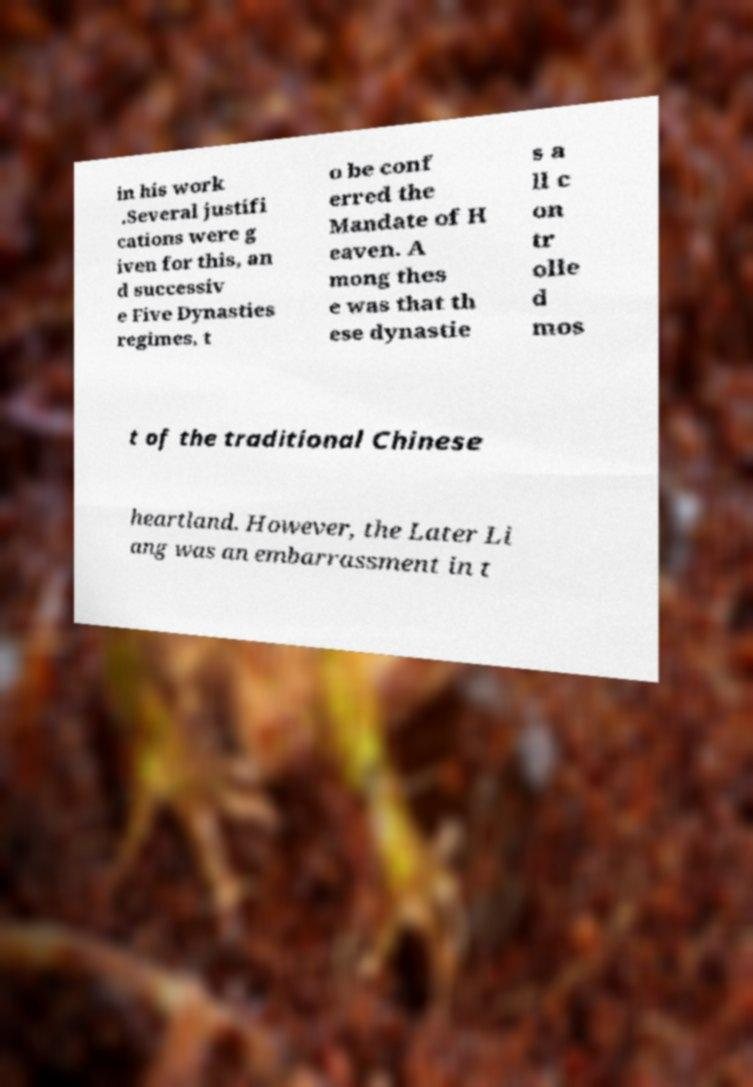There's text embedded in this image that I need extracted. Can you transcribe it verbatim? in his work .Several justifi cations were g iven for this, an d successiv e Five Dynasties regimes, t o be conf erred the Mandate of H eaven. A mong thes e was that th ese dynastie s a ll c on tr olle d mos t of the traditional Chinese heartland. However, the Later Li ang was an embarrassment in t 